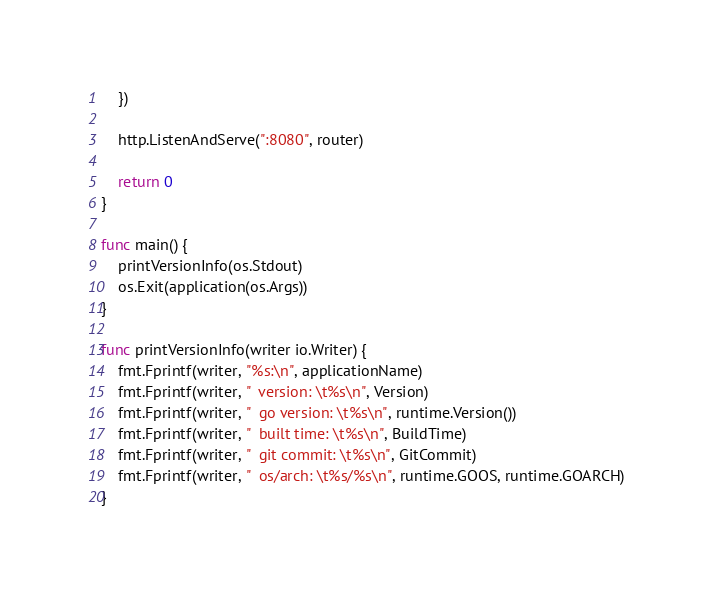Convert code to text. <code><loc_0><loc_0><loc_500><loc_500><_Go_>	})

	http.ListenAndServe(":8080", router)

	return 0
}

func main() {
	printVersionInfo(os.Stdout)
	os.Exit(application(os.Args))
}

func printVersionInfo(writer io.Writer) {
	fmt.Fprintf(writer, "%s:\n", applicationName)
	fmt.Fprintf(writer, "  version: \t%s\n", Version)
	fmt.Fprintf(writer, "  go version: \t%s\n", runtime.Version())
	fmt.Fprintf(writer, "  built time: \t%s\n", BuildTime)
	fmt.Fprintf(writer, "  git commit: \t%s\n", GitCommit)
	fmt.Fprintf(writer, "  os/arch: \t%s/%s\n", runtime.GOOS, runtime.GOARCH)
}
</code> 